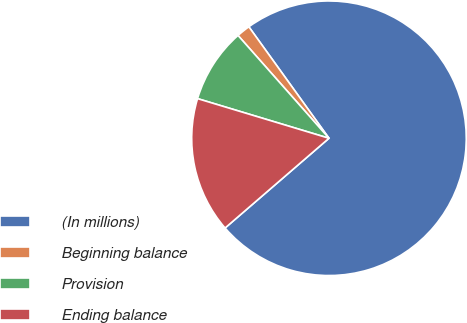Convert chart to OTSL. <chart><loc_0><loc_0><loc_500><loc_500><pie_chart><fcel>(In millions)<fcel>Beginning balance<fcel>Provision<fcel>Ending balance<nl><fcel>73.58%<fcel>1.61%<fcel>8.81%<fcel>16.0%<nl></chart> 